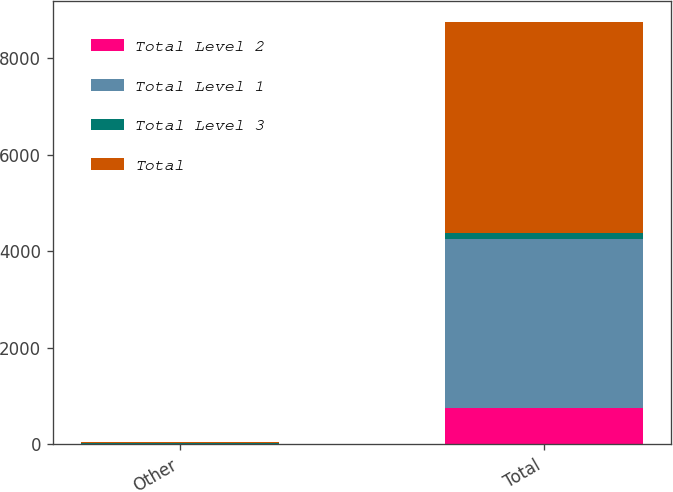Convert chart to OTSL. <chart><loc_0><loc_0><loc_500><loc_500><stacked_bar_chart><ecel><fcel>Other<fcel>Total<nl><fcel>Total Level 2<fcel>4<fcel>758<nl><fcel>Total Level 1<fcel>7<fcel>3492<nl><fcel>Total Level 3<fcel>9<fcel>124<nl><fcel>Total<fcel>20<fcel>4374<nl></chart> 